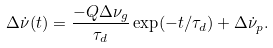Convert formula to latex. <formula><loc_0><loc_0><loc_500><loc_500>\Delta \dot { \nu } ( t ) = \frac { - Q \Delta \nu _ { g } } { \tau _ { d } } \exp ( - t / \tau _ { d } ) + \Delta \dot { \nu } _ { p } .</formula> 